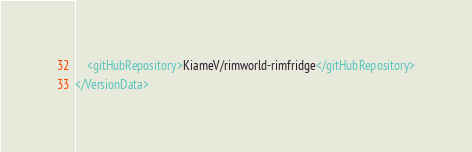<code> <loc_0><loc_0><loc_500><loc_500><_XML_>	<gitHubRepository>KiameV/rimworld-rimfridge</gitHubRepository>
</VersionData></code> 